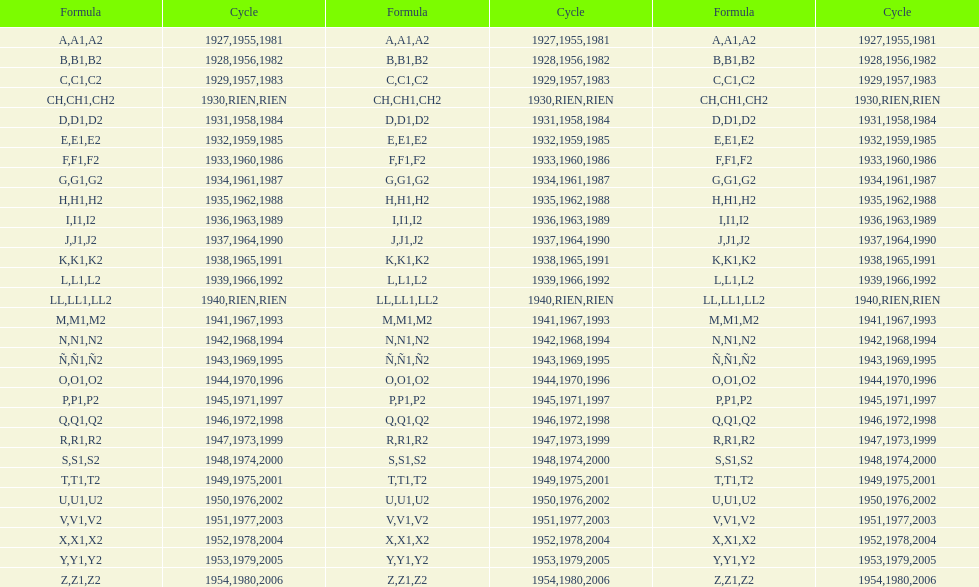Is the e code less than 1950? Yes. 